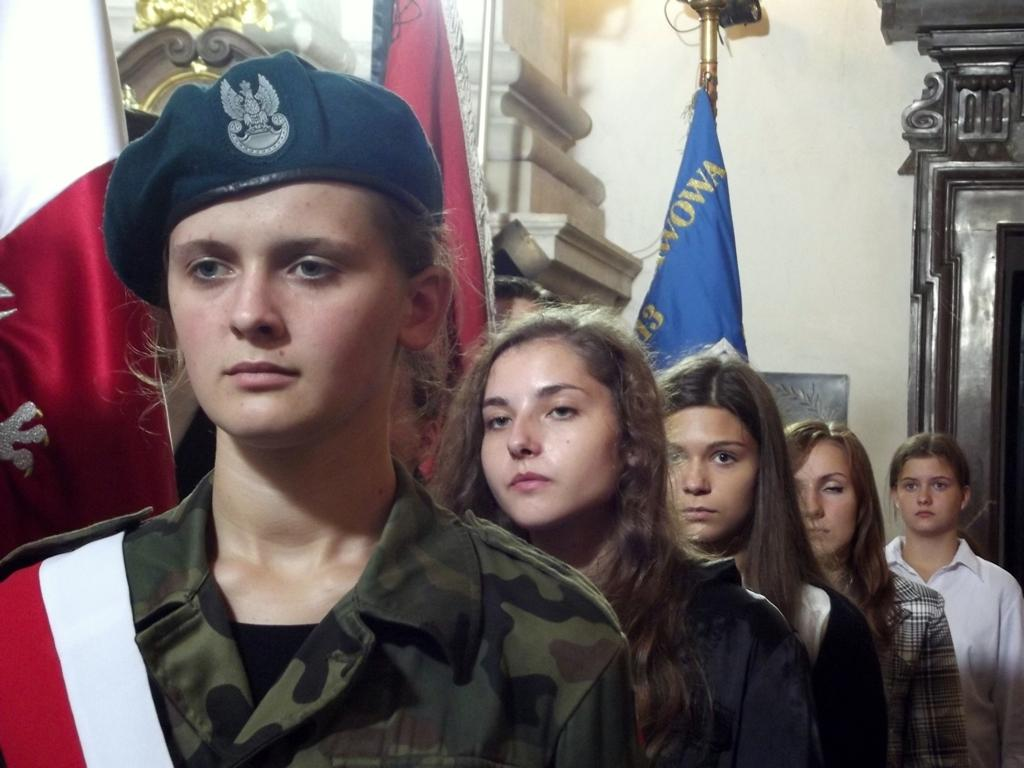How many ladies are standing in a line in the image? There are five ladies standing in a line in the image. What is the first lady wearing? The first lady is wearing a cap. What can be seen in the background of the image? There are flags and a wall in the background. What is located on the right side of the image? There is a wooden structure on the right side of the image. Can you see a boat in the image? No, there is no boat present in the image. What type of stick is being used by the ladies in the image? There is no stick visible in the image; the ladies are not holding any objects. 